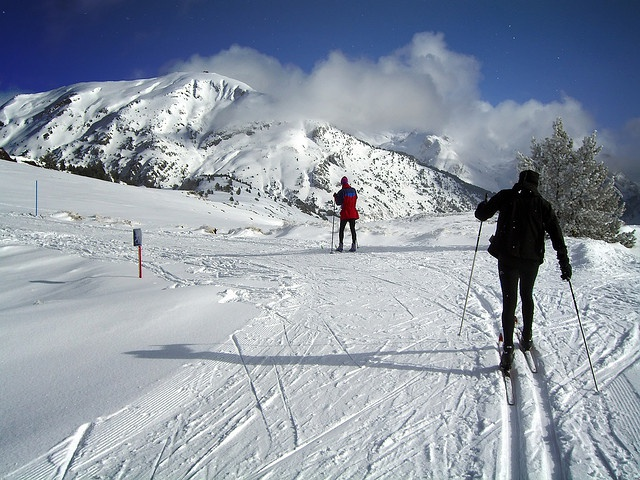Describe the objects in this image and their specific colors. I can see people in navy, black, gray, lightgray, and darkgray tones, people in navy, black, and maroon tones, skis in navy, darkgray, gray, lightgray, and black tones, and skis in navy, darkgray, gray, and lightgray tones in this image. 